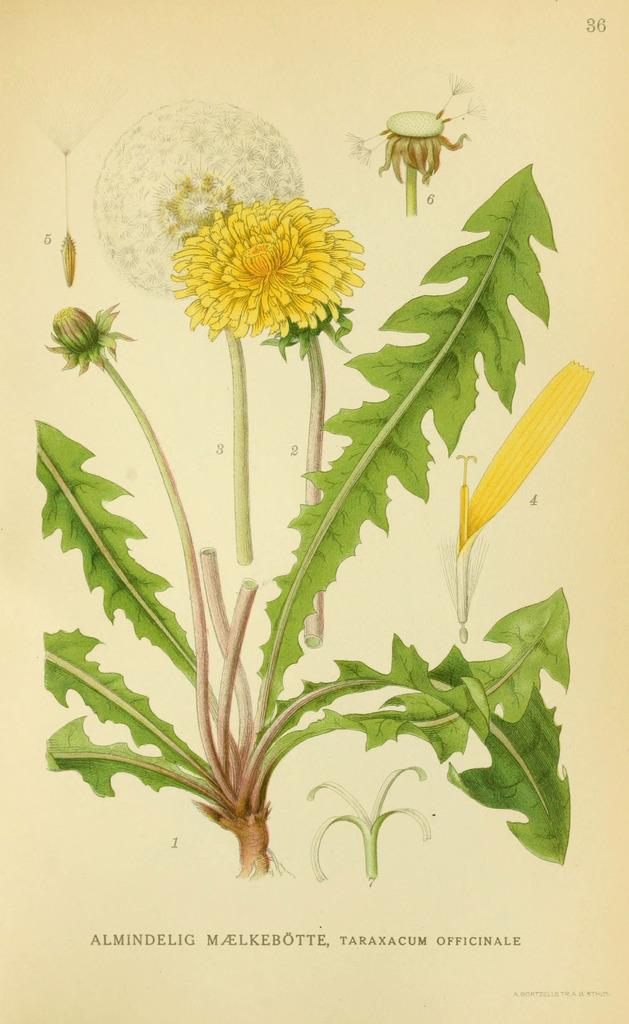What is featured on the poster in the image? The facts provided do not specify what is on the poster. What type of vegetation is present in the image? There is a plant in the image, and it has a yellow flower and a bud. How many times do the characters in the image share a kiss? There are no characters or instances of kissing present in the image. What type of shade is provided by the plant in the image? The facts provided do not mention any shade provided by the plant in the image. 